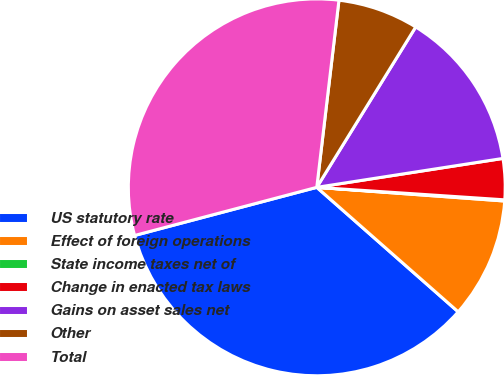<chart> <loc_0><loc_0><loc_500><loc_500><pie_chart><fcel>US statutory rate<fcel>Effect of foreign operations<fcel>State income taxes net of<fcel>Change in enacted tax laws<fcel>Gains on asset sales net<fcel>Other<fcel>Total<nl><fcel>34.4%<fcel>10.33%<fcel>0.1%<fcel>3.51%<fcel>13.75%<fcel>6.92%<fcel>30.99%<nl></chart> 